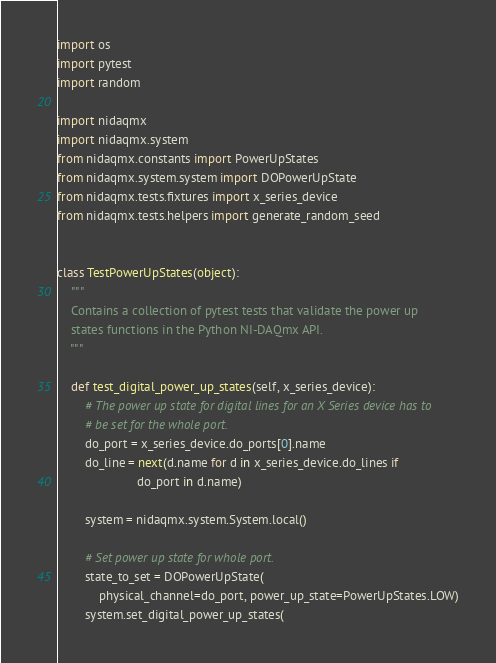Convert code to text. <code><loc_0><loc_0><loc_500><loc_500><_Python_>import os
import pytest
import random

import nidaqmx
import nidaqmx.system
from nidaqmx.constants import PowerUpStates
from nidaqmx.system.system import DOPowerUpState
from nidaqmx.tests.fixtures import x_series_device
from nidaqmx.tests.helpers import generate_random_seed


class TestPowerUpStates(object):
    """
    Contains a collection of pytest tests that validate the power up
    states functions in the Python NI-DAQmx API.
    """

    def test_digital_power_up_states(self, x_series_device):
        # The power up state for digital lines for an X Series device has to
        # be set for the whole port.
        do_port = x_series_device.do_ports[0].name
        do_line = next(d.name for d in x_series_device.do_lines if
                       do_port in d.name)

        system = nidaqmx.system.System.local()

        # Set power up state for whole port.
        state_to_set = DOPowerUpState(
            physical_channel=do_port, power_up_state=PowerUpStates.LOW)
        system.set_digital_power_up_states(</code> 